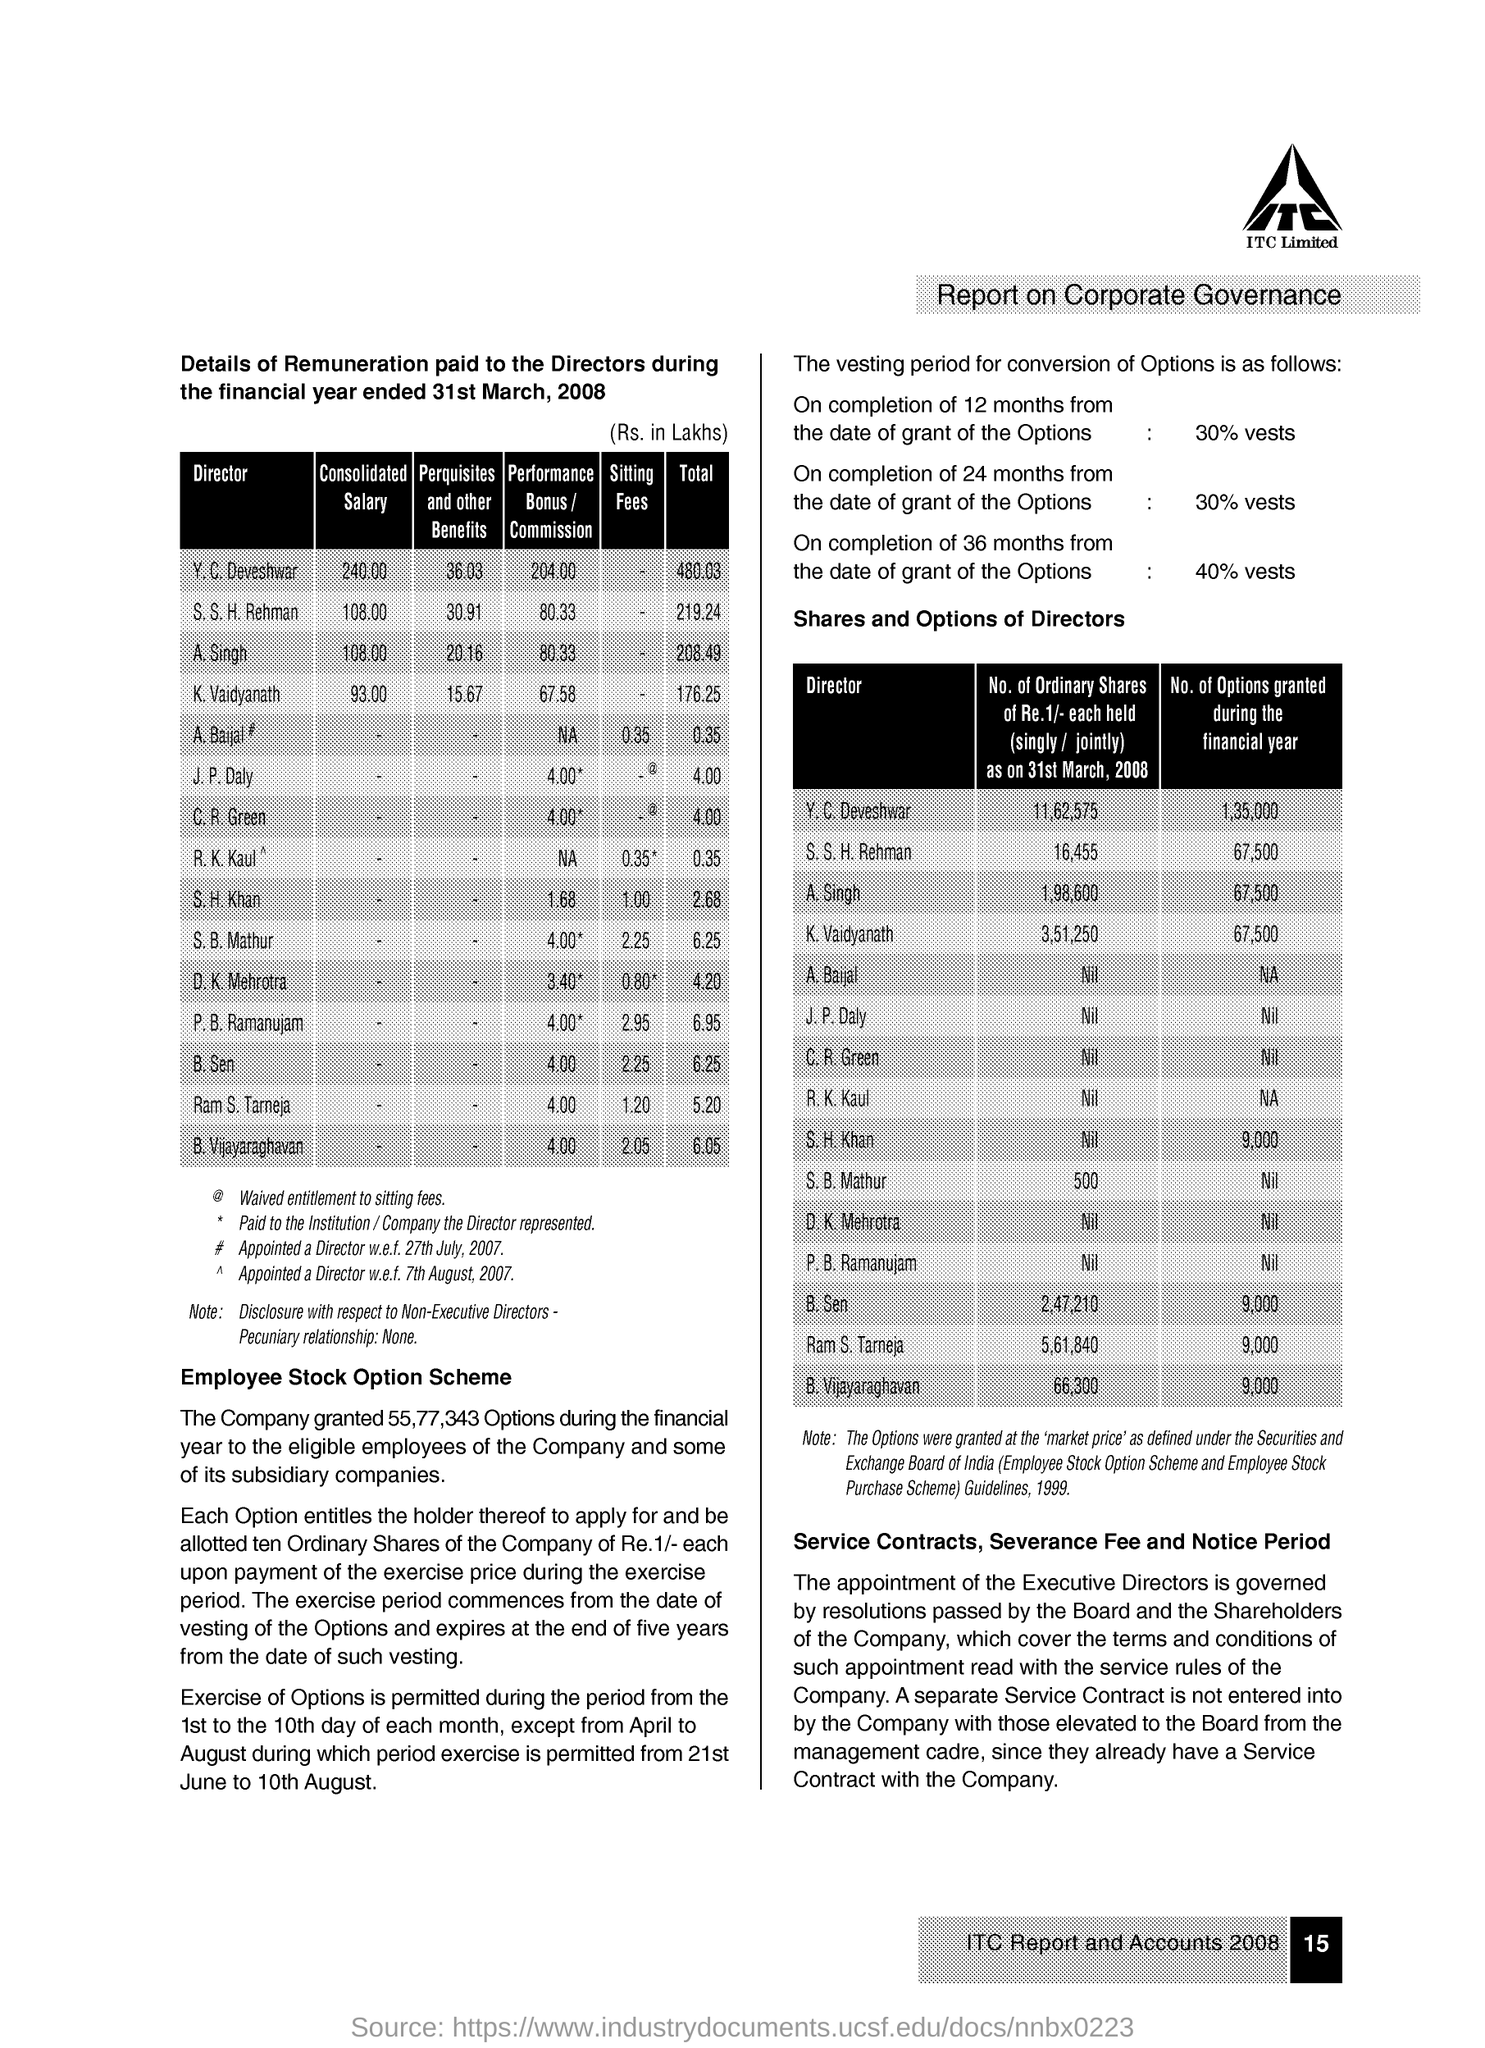Give some essential details in this illustration. The total for K. Vaidyanath is 176.25. The consolidated salary for K. Vaidyanath is 93. The total for S. S. H. Rehman is 219.24. The total for Y. C. Deveshwar is 480.03. The sitting fees for S. B. Mathur are 2.25. 